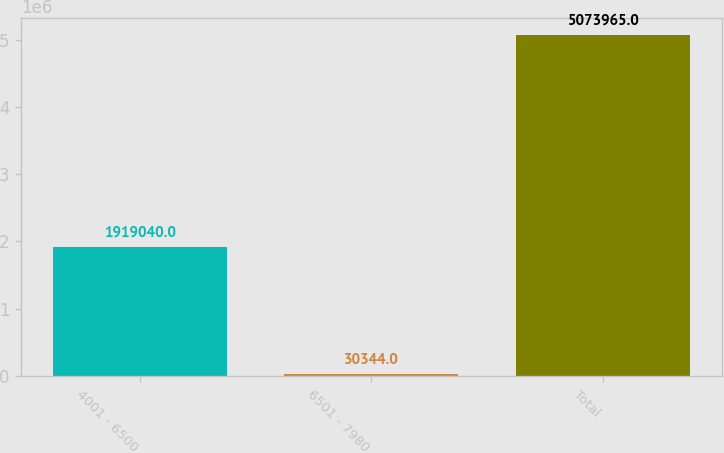<chart> <loc_0><loc_0><loc_500><loc_500><bar_chart><fcel>4001 - 6500<fcel>6501 - 7980<fcel>Total<nl><fcel>1.91904e+06<fcel>30344<fcel>5.07396e+06<nl></chart> 